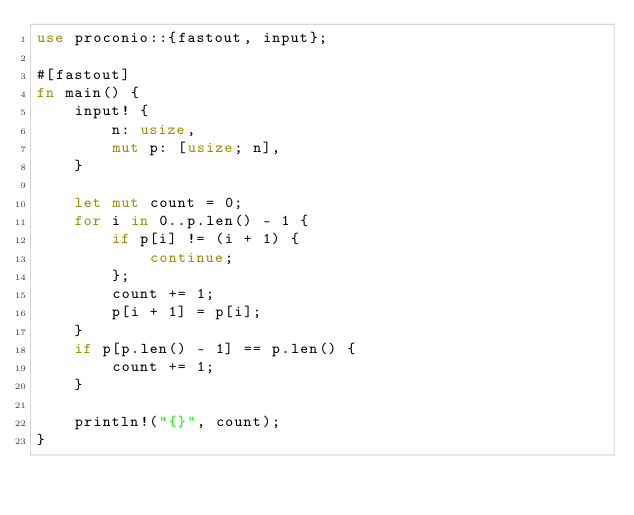<code> <loc_0><loc_0><loc_500><loc_500><_Rust_>use proconio::{fastout, input};

#[fastout]
fn main() {
    input! {
        n: usize,
        mut p: [usize; n],
    }

    let mut count = 0;
    for i in 0..p.len() - 1 {
        if p[i] != (i + 1) {
            continue;
        };
        count += 1;
        p[i + 1] = p[i];
    }
    if p[p.len() - 1] == p.len() {
        count += 1;
    }

    println!("{}", count);
}
</code> 